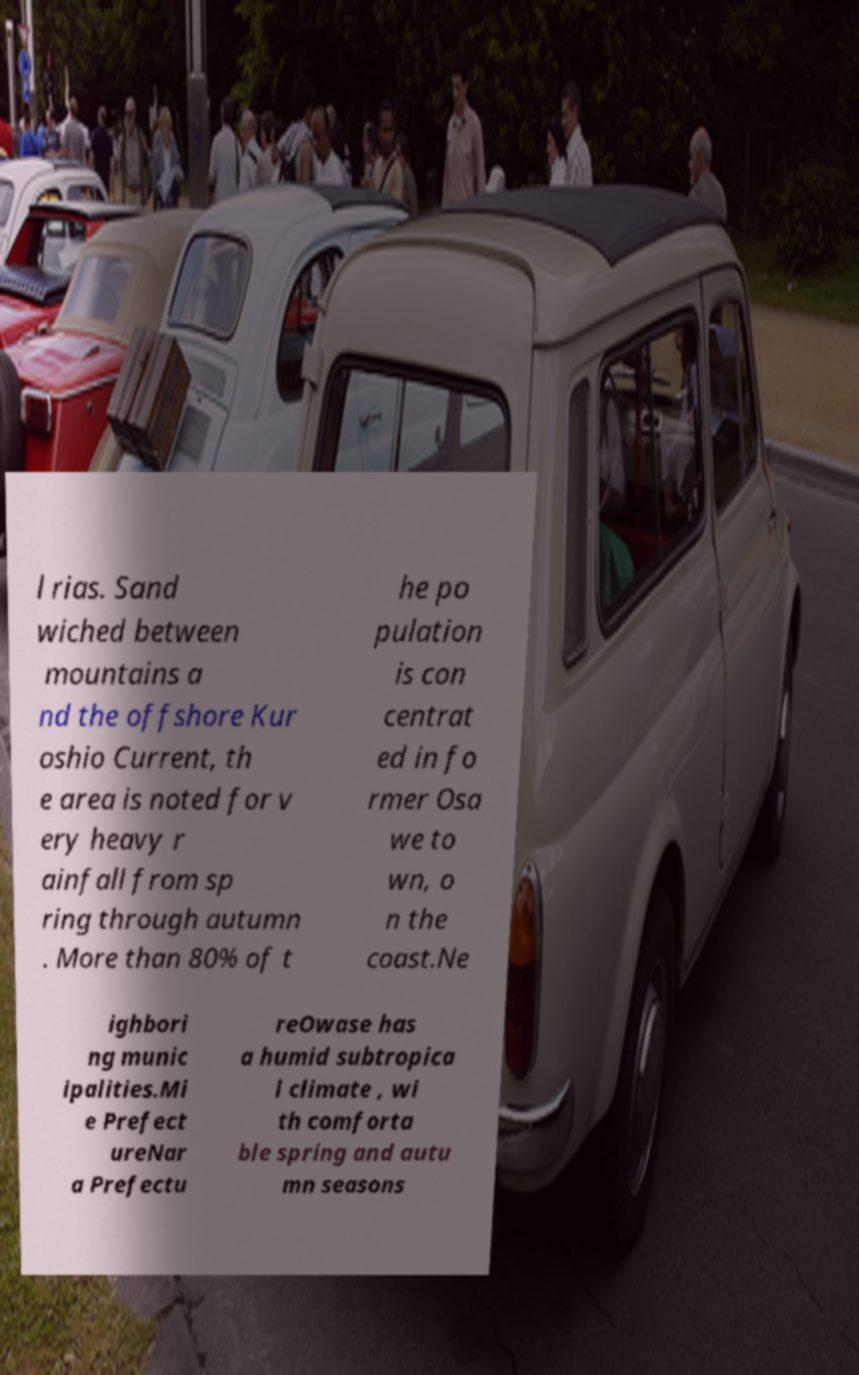Can you accurately transcribe the text from the provided image for me? l rias. Sand wiched between mountains a nd the offshore Kur oshio Current, th e area is noted for v ery heavy r ainfall from sp ring through autumn . More than 80% of t he po pulation is con centrat ed in fo rmer Osa we to wn, o n the coast.Ne ighbori ng munic ipalities.Mi e Prefect ureNar a Prefectu reOwase has a humid subtropica l climate , wi th comforta ble spring and autu mn seasons 